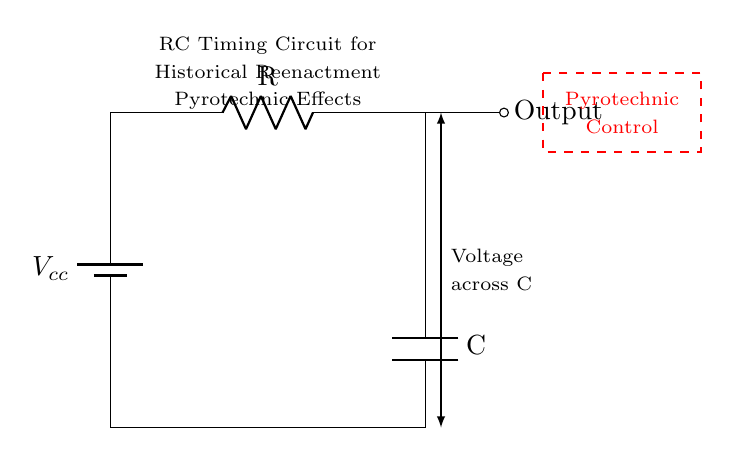What is the type of circuit shown? The circuit is a Resistor-Capacitor timing circuit, which contains a resistor and a capacitor to generate a specific timing function for the output.
Answer: Resistor-Capacitor What are the main components of the circuit? The main components are a resistor, a capacitor, and a battery. The resistor is for limiting current, the capacitor for storing charge, and the battery provides the voltage supply.
Answer: Resistor, capacitor, battery What is the purpose of the capacitor in this circuit? The capacitor in an RC timing circuit stores electrical energy and releases it over time, which is essential for creating delayed output or timing sequences.
Answer: Timing/delay What happens to the output when the capacitor is fully charged? When the capacitor is fully charged, it reaches its maximum voltage, causing the current to stop flowing through it, and the output voltage stabilizes.
Answer: Stabilizes/max voltage How does increasing the resistance affect the timing? Increasing the resistance increases the time constant of the circuit (time taken to charge/discharge), resulting in a longer time delay for the output signal.
Answer: Longer time delay What is the significance of the pyrotechnic control block in the circuit? The pyrotechnic control block allows for triggering or managing pyrotechnic effects based on the timing provided by the RC circuit, ensuring precise execution during reenactments.
Answer: Triggering pyrotechnic effects 